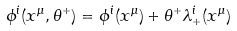<formula> <loc_0><loc_0><loc_500><loc_500>\phi ^ { i } ( x ^ { \mu } , \theta ^ { + } ) & = \phi ^ { i } ( x ^ { \mu } ) + \theta ^ { + } \lambda ^ { i } _ { + } ( x ^ { \mu } )</formula> 